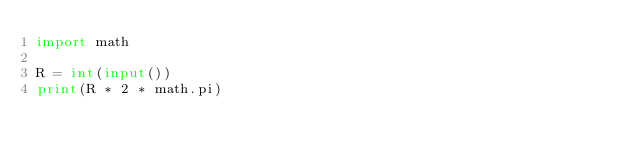<code> <loc_0><loc_0><loc_500><loc_500><_Python_>import math

R = int(input())
print(R * 2 * math.pi)</code> 